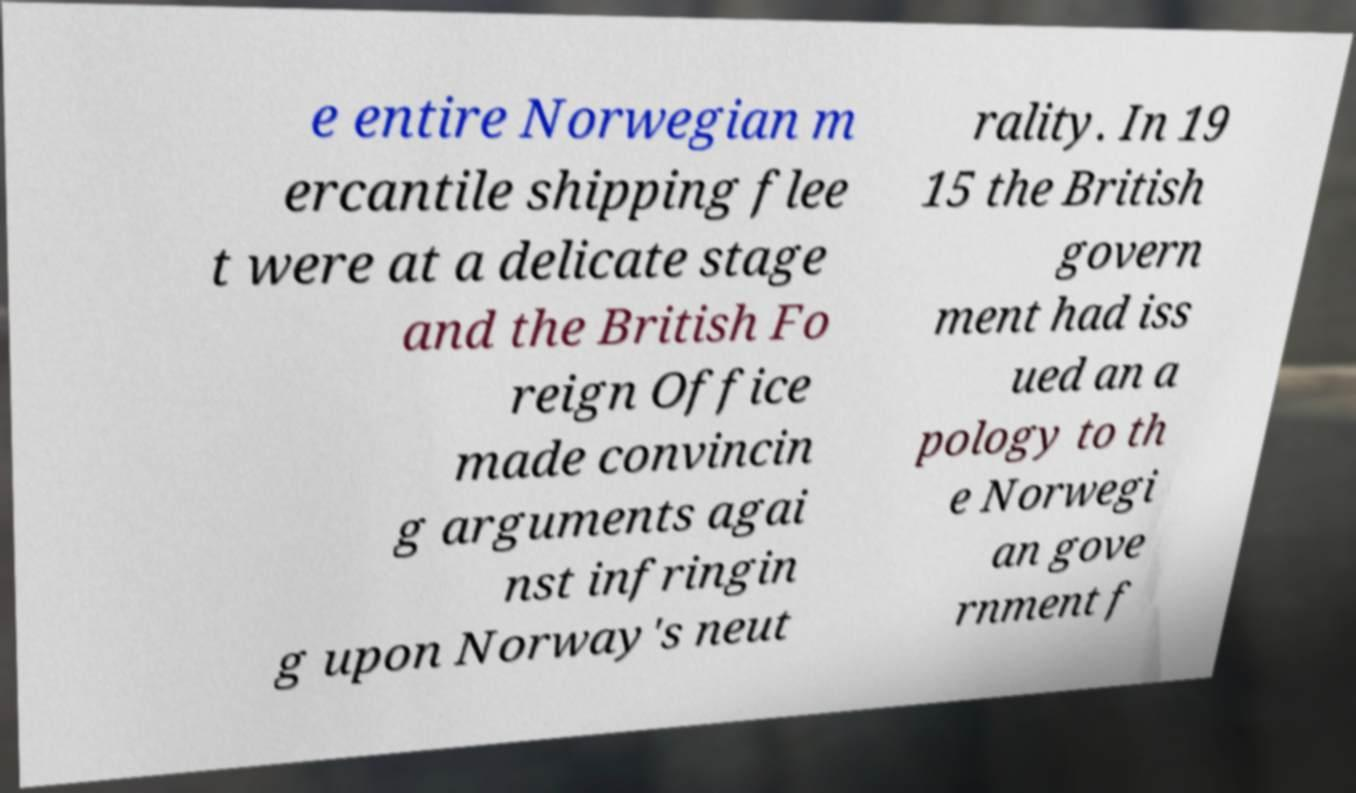Please identify and transcribe the text found in this image. e entire Norwegian m ercantile shipping flee t were at a delicate stage and the British Fo reign Office made convincin g arguments agai nst infringin g upon Norway's neut rality. In 19 15 the British govern ment had iss ued an a pology to th e Norwegi an gove rnment f 